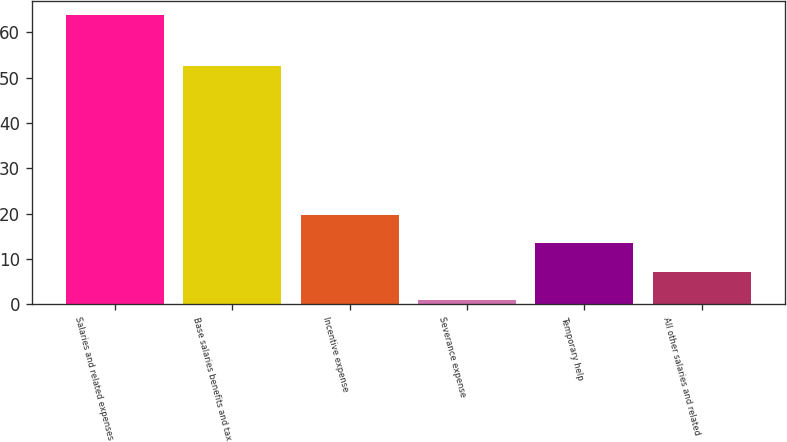<chart> <loc_0><loc_0><loc_500><loc_500><bar_chart><fcel>Salaries and related expenses<fcel>Base salaries benefits and tax<fcel>Incentive expense<fcel>Severance expense<fcel>Temporary help<fcel>All other salaries and related<nl><fcel>63.8<fcel>52.7<fcel>19.77<fcel>0.9<fcel>13.48<fcel>7.19<nl></chart> 